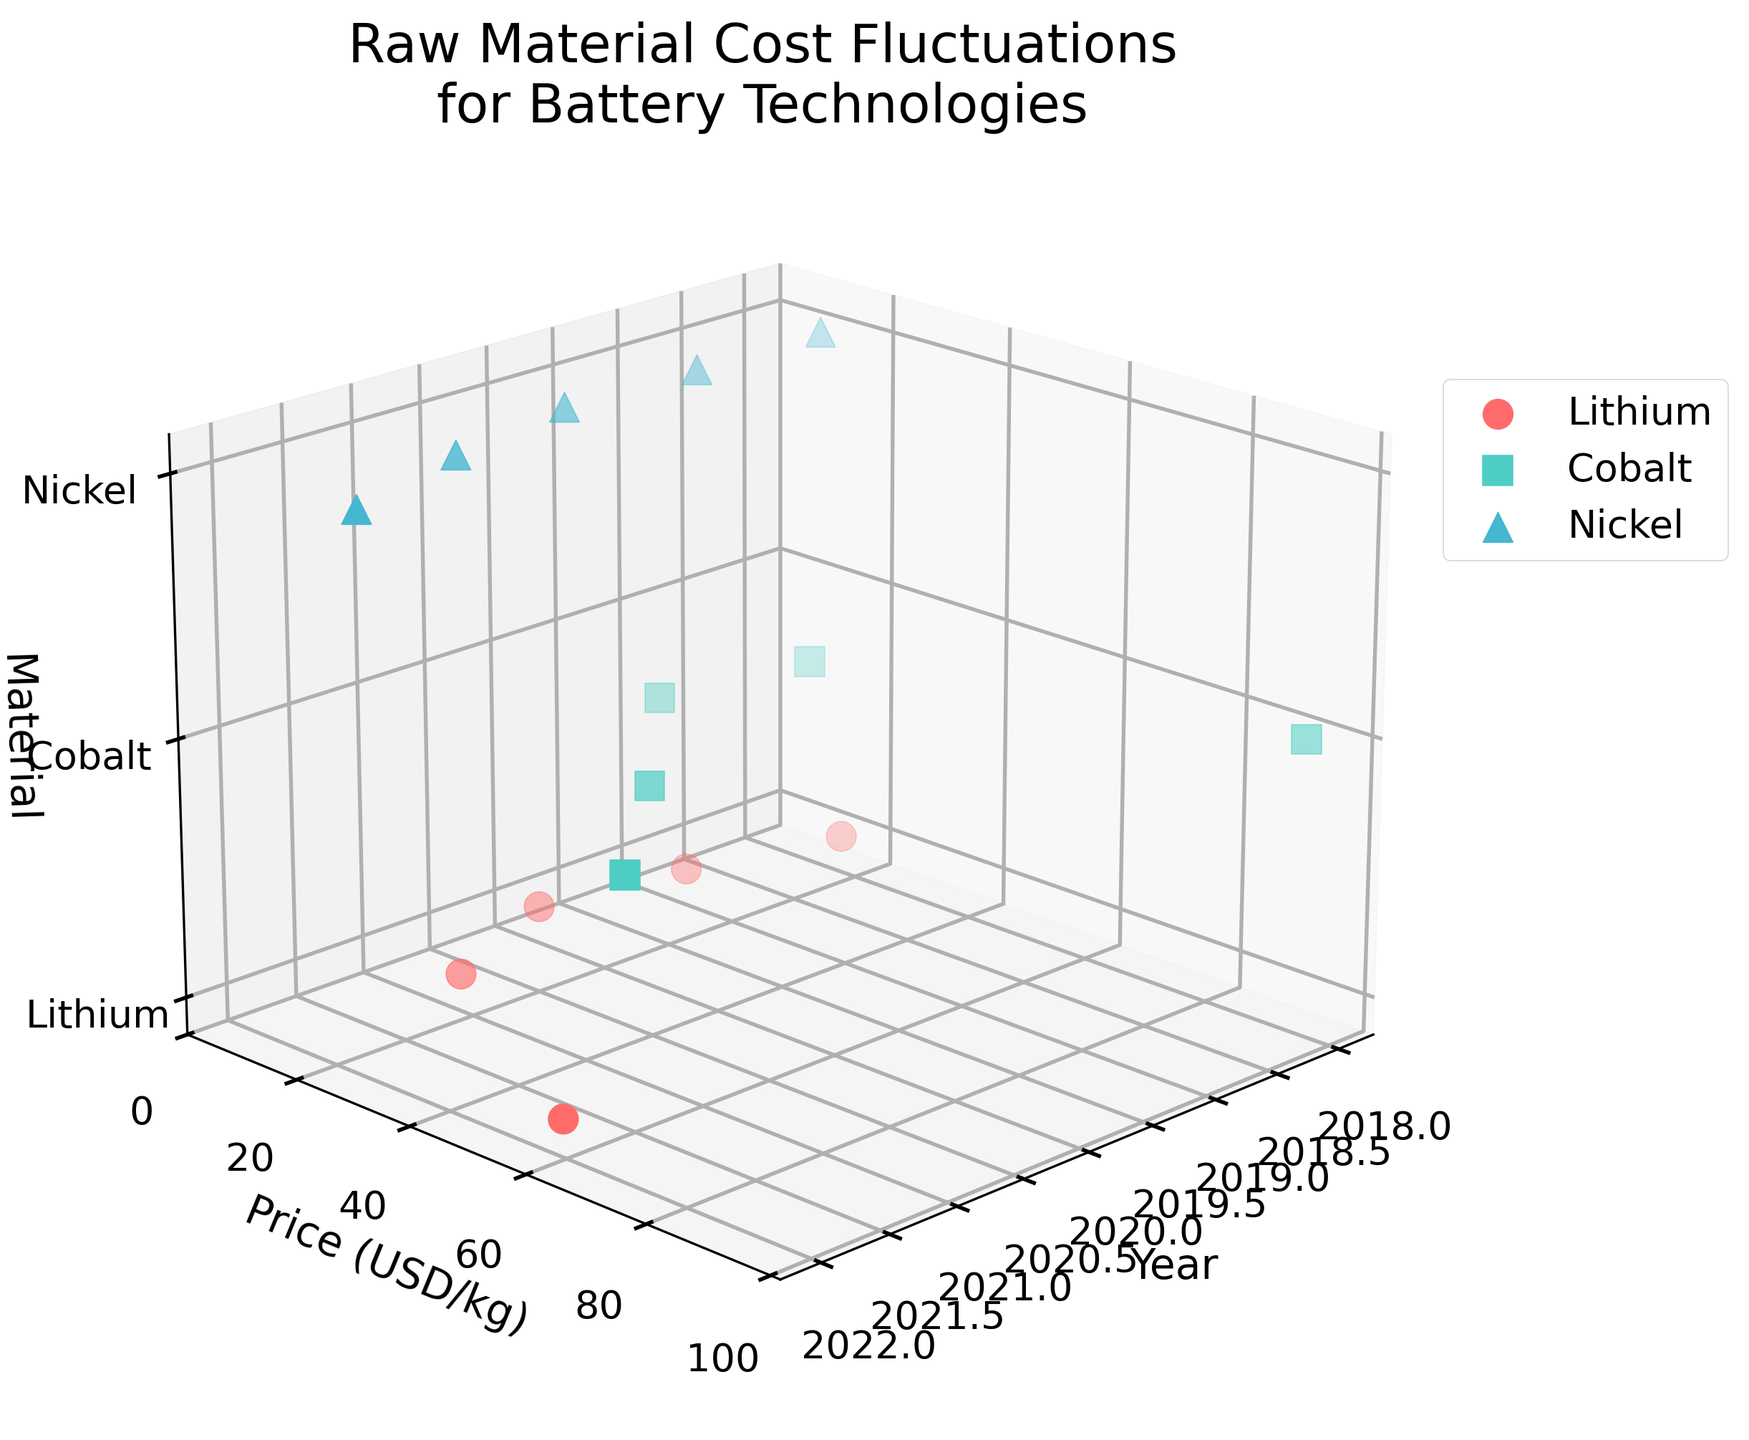What are the prices of Lithium in 2022? To find the price of Lithium in 2022, locate the year 2022 on the x-axis and then find the Lithium data point based on its position (as it will be marked with a specific color and marker). The corresponding value on the y-axis will indicate its price.
Answer: 59.5 USD/kg What trend can be observed in the price of Cobalt from 2018 to 2022? Identify Cobalt data points from 2018 to 2022, and observe the trajectory of the points based on the y-axis (price) values. Note the fluctuations in price values.
Answer: Increasing trend with fluctuations Which year had the highest price for Nickel, and what was the value? By looking at the Nickel data points from 2018 to 2022, find the one with the highest position on the y-axis. The corresponding year on the x-axis will indicate the year and the y-axis value will show the price.
Answer: 2022, 25.6 USD/kg How does the price of Lithium in 2020 compare to the price of Nickel in the same year? Locate the prices of both Lithium and Nickel in 2020. To compare, observe their respective positions on the y-axis.
Answer: Lithium is lower Among Lithium, Cobalt, and Nickel, which material saw the greatest fluctuation in price over the years? Identify and compare the range of prices for Lithium, Cobalt, and Nickel by finding the difference between their maximum and minimum y-axis values.
Answer: Lithium What is the average price of Cobalt over the given years? Add the prices of Cobalt in each year from 2018 to 2022 and divide by the number of years (5). Calculation steps: (95.2 + 33.7 + 30.1 + 51.3 + 70.2) / 5 = 56.1
Answer: 56.1 USD/kg In which year was there the smallest price difference between Lithium and Nickel? Calculate the price difference between Lithium and Nickel for each year by subtracting their respective prices. Identify the year with the smallest difference.
Answer: 2019 What was the year-to-year increase in the price of Lithium from 2020 to 2021? Subtract the 2020 price of Lithium from its 2021 price to find the year-to-year increase: 17.9 - 8.2 = 9.7
Answer: 9.7 USD/kg How do the price trends of Cobalt and Nickel compare over the years? Examine the data points for Cobalt and Nickel from 2018 to 2022. Identify the trend of each material by observing their price values and whether they increase, decrease, or stay constant over time.
Answer: Cobalt has more fluctuations, Nickel shows a gradual increase 